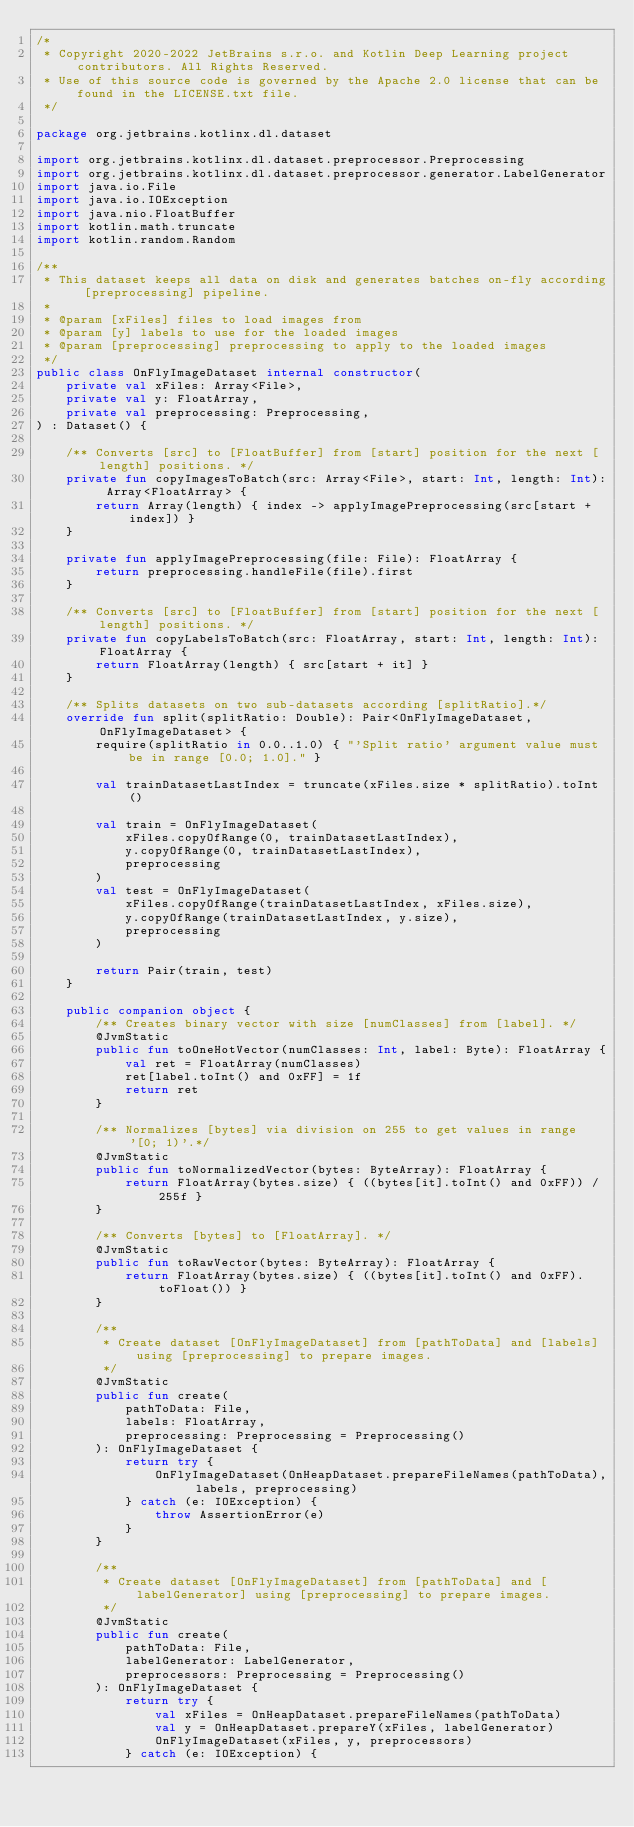Convert code to text. <code><loc_0><loc_0><loc_500><loc_500><_Kotlin_>/*
 * Copyright 2020-2022 JetBrains s.r.o. and Kotlin Deep Learning project contributors. All Rights Reserved.
 * Use of this source code is governed by the Apache 2.0 license that can be found in the LICENSE.txt file.
 */

package org.jetbrains.kotlinx.dl.dataset

import org.jetbrains.kotlinx.dl.dataset.preprocessor.Preprocessing
import org.jetbrains.kotlinx.dl.dataset.preprocessor.generator.LabelGenerator
import java.io.File
import java.io.IOException
import java.nio.FloatBuffer
import kotlin.math.truncate
import kotlin.random.Random

/**
 * This dataset keeps all data on disk and generates batches on-fly according [preprocessing] pipeline.
 *
 * @param [xFiles] files to load images from
 * @param [y] labels to use for the loaded images
 * @param [preprocessing] preprocessing to apply to the loaded images
 */
public class OnFlyImageDataset internal constructor(
    private val xFiles: Array<File>,
    private val y: FloatArray,
    private val preprocessing: Preprocessing,
) : Dataset() {

    /** Converts [src] to [FloatBuffer] from [start] position for the next [length] positions. */
    private fun copyImagesToBatch(src: Array<File>, start: Int, length: Int): Array<FloatArray> {
        return Array(length) { index -> applyImagePreprocessing(src[start + index]) }
    }

    private fun applyImagePreprocessing(file: File): FloatArray {
        return preprocessing.handleFile(file).first
    }

    /** Converts [src] to [FloatBuffer] from [start] position for the next [length] positions. */
    private fun copyLabelsToBatch(src: FloatArray, start: Int, length: Int): FloatArray {
        return FloatArray(length) { src[start + it] }
    }

    /** Splits datasets on two sub-datasets according [splitRatio].*/
    override fun split(splitRatio: Double): Pair<OnFlyImageDataset, OnFlyImageDataset> {
        require(splitRatio in 0.0..1.0) { "'Split ratio' argument value must be in range [0.0; 1.0]." }

        val trainDatasetLastIndex = truncate(xFiles.size * splitRatio).toInt()

        val train = OnFlyImageDataset(
            xFiles.copyOfRange(0, trainDatasetLastIndex),
            y.copyOfRange(0, trainDatasetLastIndex),
            preprocessing
        )
        val test = OnFlyImageDataset(
            xFiles.copyOfRange(trainDatasetLastIndex, xFiles.size),
            y.copyOfRange(trainDatasetLastIndex, y.size),
            preprocessing
        )

        return Pair(train, test)
    }

    public companion object {
        /** Creates binary vector with size [numClasses] from [label]. */
        @JvmStatic
        public fun toOneHotVector(numClasses: Int, label: Byte): FloatArray {
            val ret = FloatArray(numClasses)
            ret[label.toInt() and 0xFF] = 1f
            return ret
        }

        /** Normalizes [bytes] via division on 255 to get values in range '[0; 1)'.*/
        @JvmStatic
        public fun toNormalizedVector(bytes: ByteArray): FloatArray {
            return FloatArray(bytes.size) { ((bytes[it].toInt() and 0xFF)) / 255f }
        }

        /** Converts [bytes] to [FloatArray]. */
        @JvmStatic
        public fun toRawVector(bytes: ByteArray): FloatArray {
            return FloatArray(bytes.size) { ((bytes[it].toInt() and 0xFF).toFloat()) }
        }

        /**
         * Create dataset [OnFlyImageDataset] from [pathToData] and [labels] using [preprocessing] to prepare images.
         */
        @JvmStatic
        public fun create(
            pathToData: File,
            labels: FloatArray,
            preprocessing: Preprocessing = Preprocessing()
        ): OnFlyImageDataset {
            return try {
                OnFlyImageDataset(OnHeapDataset.prepareFileNames(pathToData), labels, preprocessing)
            } catch (e: IOException) {
                throw AssertionError(e)
            }
        }

        /**
         * Create dataset [OnFlyImageDataset] from [pathToData] and [labelGenerator] using [preprocessing] to prepare images.
         */
        @JvmStatic
        public fun create(
            pathToData: File,
            labelGenerator: LabelGenerator,
            preprocessors: Preprocessing = Preprocessing()
        ): OnFlyImageDataset {
            return try {
                val xFiles = OnHeapDataset.prepareFileNames(pathToData)
                val y = OnHeapDataset.prepareY(xFiles, labelGenerator)
                OnFlyImageDataset(xFiles, y, preprocessors)
            } catch (e: IOException) {</code> 